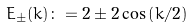Convert formula to latex. <formula><loc_0><loc_0><loc_500><loc_500>E _ { \pm } ( k ) \colon = 2 \pm 2 \cos \left ( k / 2 \right )</formula> 